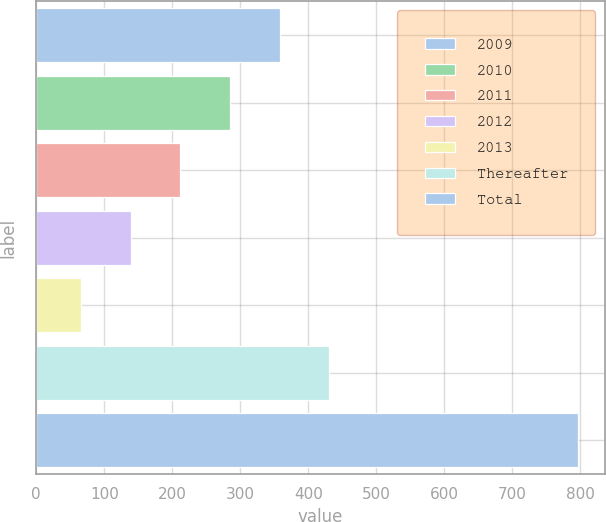<chart> <loc_0><loc_0><loc_500><loc_500><bar_chart><fcel>2009<fcel>2010<fcel>2011<fcel>2012<fcel>2013<fcel>Thereafter<fcel>Total<nl><fcel>358<fcel>285<fcel>212<fcel>139<fcel>66<fcel>431<fcel>796<nl></chart> 